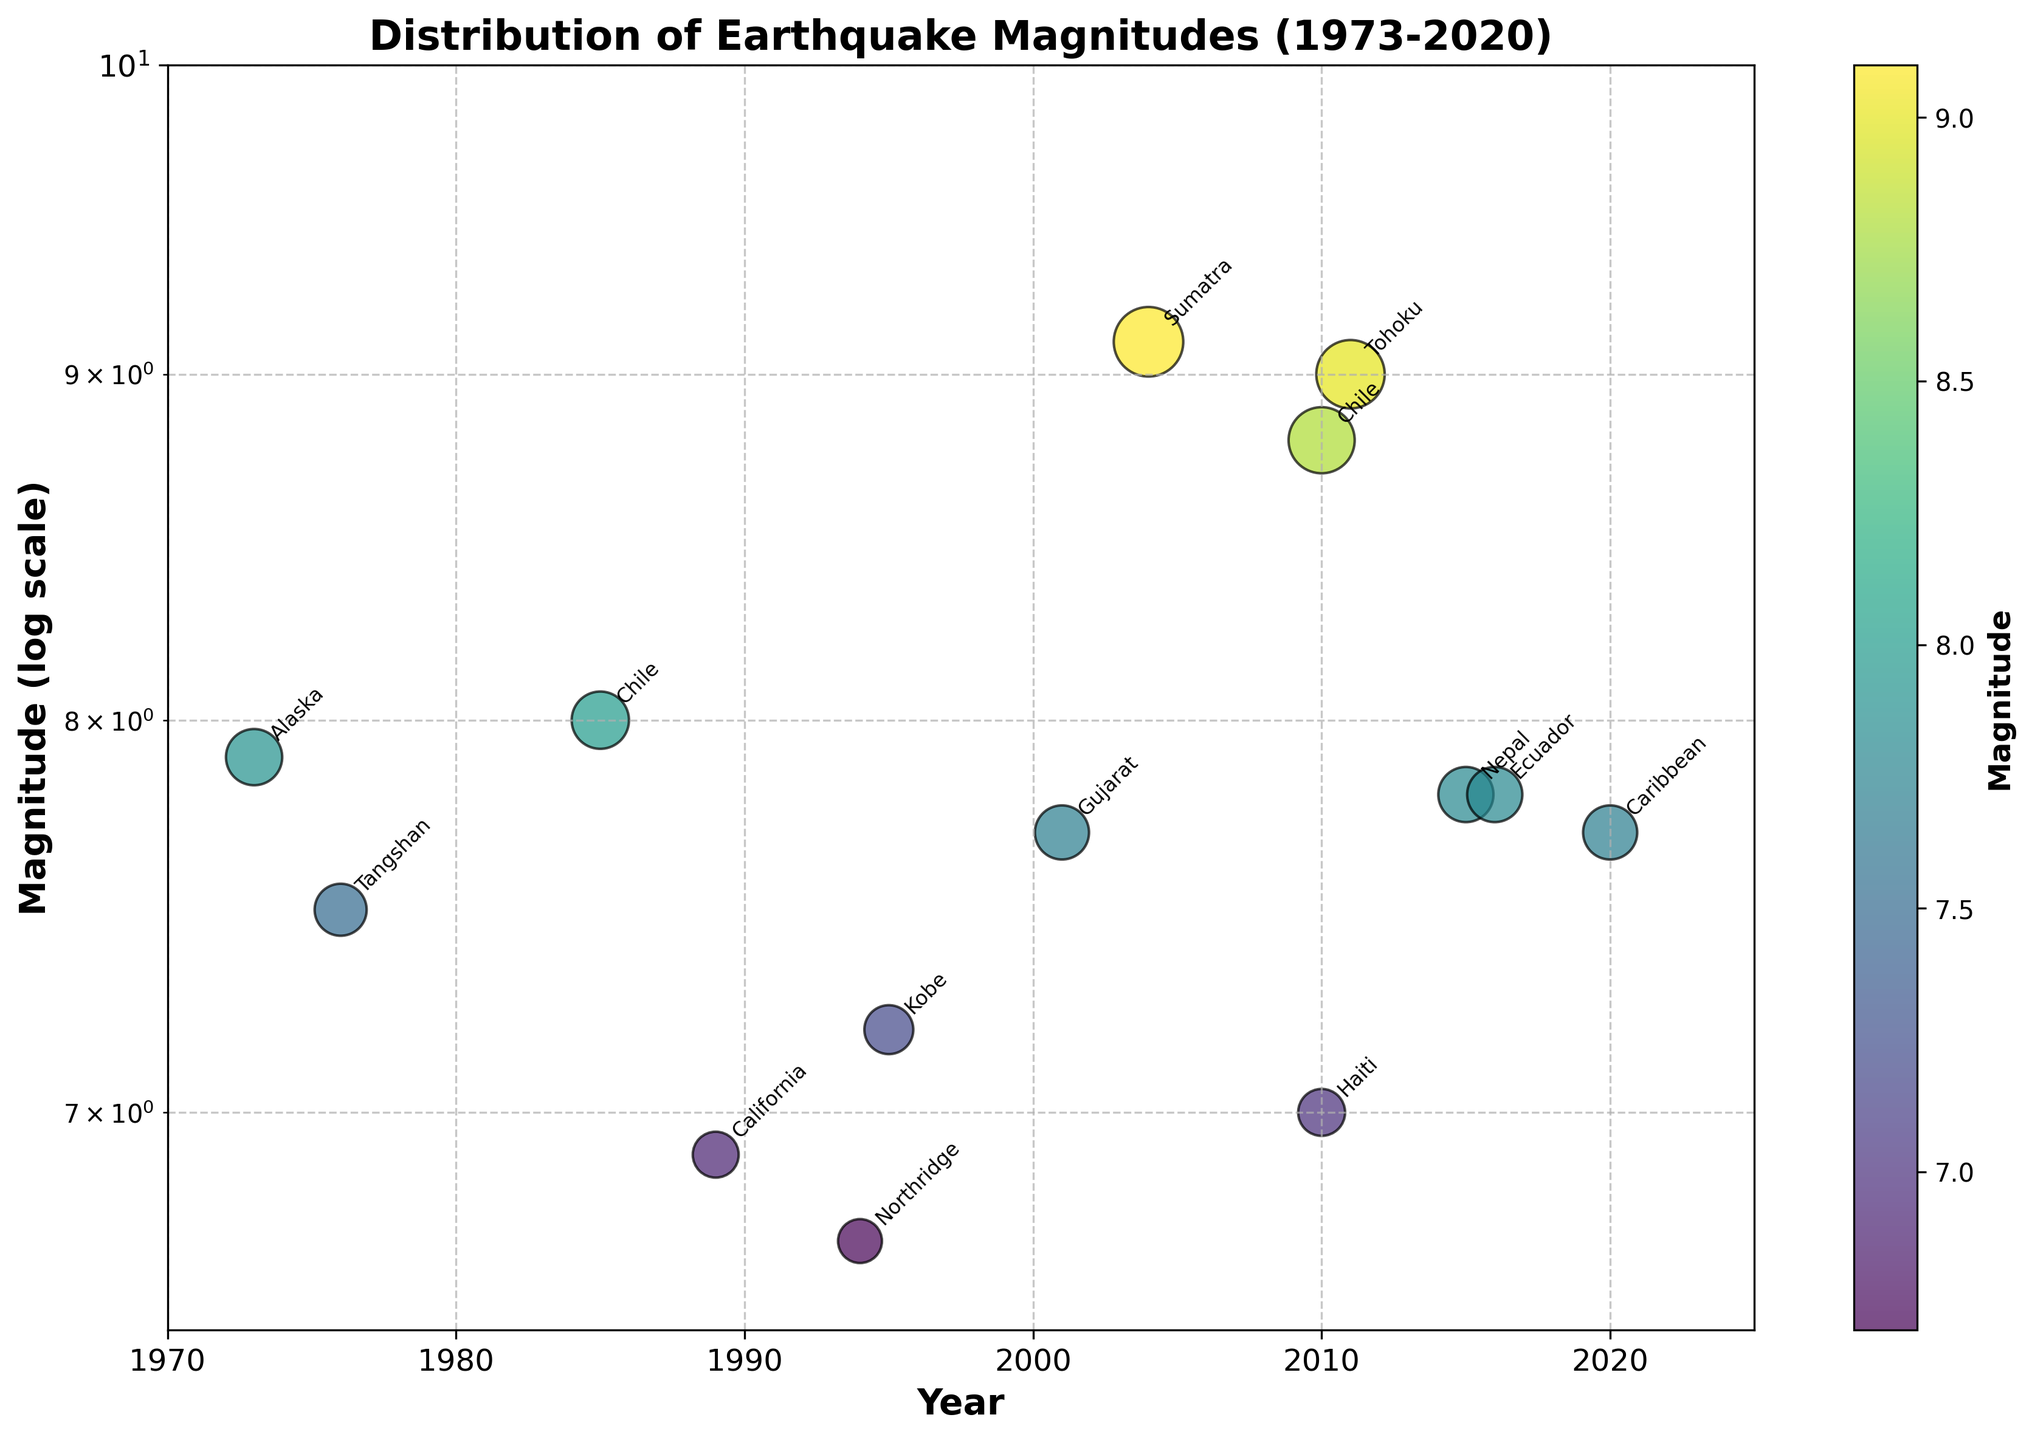What is the title of the plot? The title is written at the top of the plot.
Answer: Distribution of Earthquake Magnitudes (1973-2020) What is the highest earthquake magnitude shown on the plot? The highest magnitude corresponds to the maximum value on the y-axis, which is also visibly marked.
Answer: 9.1 In which year did the earthquake with a magnitude of 9.1 occur? By locating the 9.1 magnitude on the vertical axis (log scale) and tracing horizontally to find the corresponding year on the x-axis.
Answer: 2004 How does the magnitude of the 1985 Chile earthquake compare to the 2010 Chile earthquake? Locate both points on the plot by their year and magnitude, and then compare their magnitudes.
Answer: The 2010 Chile earthquake (8.8) is greater than the 1985 Chile earthquake (8.0) What region had an earthquake with a magnitude approximately 6.9? Find a point with a magnitude of 6.9 on the y-axis and trace it back to identify the corresponding data label.
Answer: California Which earthquake is depicted with the largest point size on the plot? The largest point size corresponds to the earthquake with the most significant magnitude because sizes are proportional to magnitude cubed.
Answer: Sumatra, 2004, 9.1 magnitude How many earthquakes shown had a magnitude of 7.8? Count the number of points with a magnitude of 7.8 on the vertical axis.
Answer: 2 (Nepal in 2015, Ecuador in 2016) What is the range of years shown on the x-axis? Look at the minimum and maximum values on the x-axis.
Answer: 1970 to 2025 